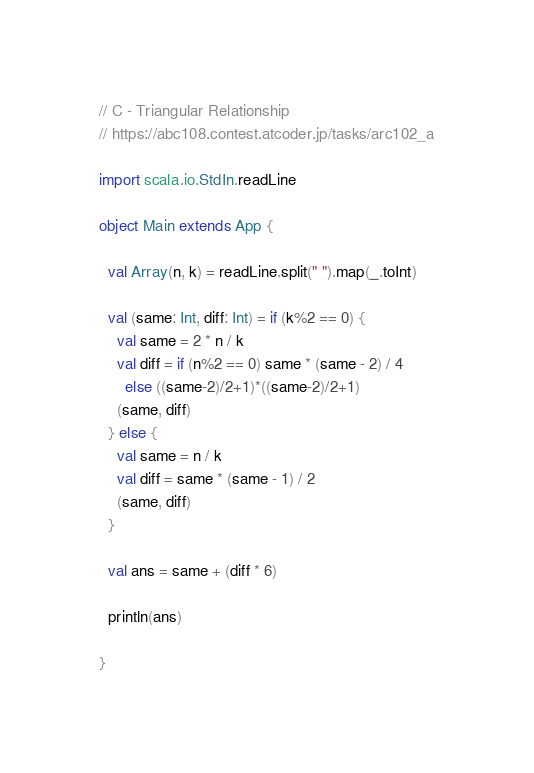<code> <loc_0><loc_0><loc_500><loc_500><_Scala_>// C - Triangular Relationship
// https://abc108.contest.atcoder.jp/tasks/arc102_a

import scala.io.StdIn.readLine

object Main extends App {

  val Array(n, k) = readLine.split(" ").map(_.toInt)

  val (same: Int, diff: Int) = if (k%2 == 0) {
    val same = 2 * n / k
    val diff = if (n%2 == 0) same * (same - 2) / 4
      else ((same-2)/2+1)*((same-2)/2+1) 
    (same, diff)
  } else {
    val same = n / k
    val diff = same * (same - 1) / 2
    (same, diff)
  }

  val ans = same + (diff * 6)

  println(ans)

}
</code> 